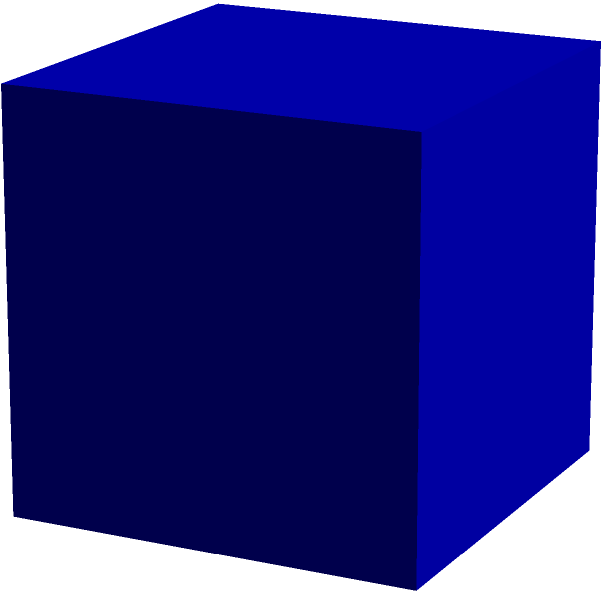Your urban sneaker brand is launching a new limited-edition model that comes in a cube-shaped box. The edge length of the box is 12 cm. To create a unique unboxing experience, you want to cover the entire surface of the box with a special textured material. How many square centimeters of this material will you need for each box? Let's approach this step-by-step:

1) First, recall the formula for the surface area of a cube:
   Surface Area = 6 * (side length)²

2) We're given that the edge length of the cube is 12 cm.

3) Let's substitute this into our formula:
   Surface Area = 6 * (12 cm)²

4) Now, let's calculate:
   Surface Area = 6 * 144 cm²
   
5) Simplify:
   Surface Area = 864 cm²

Therefore, you will need 864 square centimeters of the special textured material for each box.
Answer: 864 cm² 